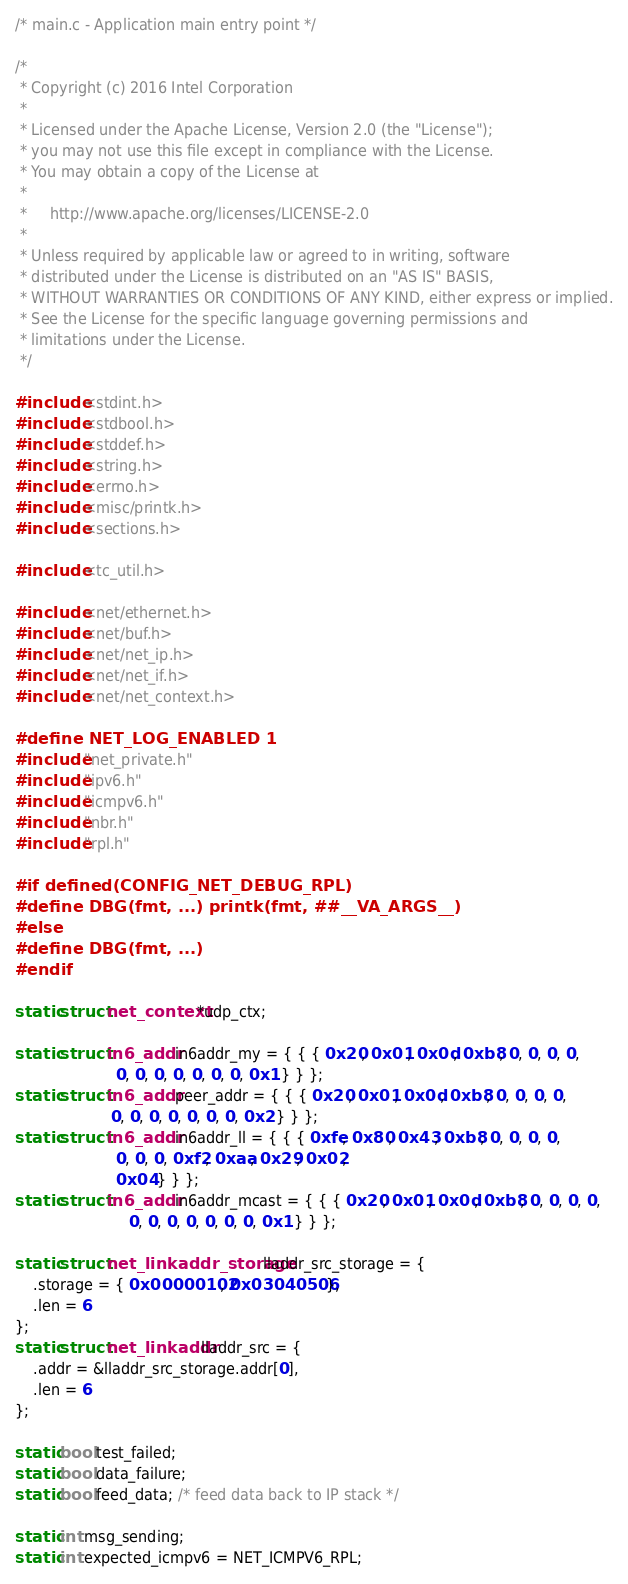<code> <loc_0><loc_0><loc_500><loc_500><_C_>/* main.c - Application main entry point */

/*
 * Copyright (c) 2016 Intel Corporation
 *
 * Licensed under the Apache License, Version 2.0 (the "License");
 * you may not use this file except in compliance with the License.
 * You may obtain a copy of the License at
 *
 *     http://www.apache.org/licenses/LICENSE-2.0
 *
 * Unless required by applicable law or agreed to in writing, software
 * distributed under the License is distributed on an "AS IS" BASIS,
 * WITHOUT WARRANTIES OR CONDITIONS OF ANY KIND, either express or implied.
 * See the License for the specific language governing permissions and
 * limitations under the License.
 */

#include <stdint.h>
#include <stdbool.h>
#include <stddef.h>
#include <string.h>
#include <errno.h>
#include <misc/printk.h>
#include <sections.h>

#include <tc_util.h>

#include <net/ethernet.h>
#include <net/buf.h>
#include <net/net_ip.h>
#include <net/net_if.h>
#include <net/net_context.h>

#define NET_LOG_ENABLED 1
#include "net_private.h"
#include "ipv6.h"
#include "icmpv6.h"
#include "nbr.h"
#include "rpl.h"

#if defined(CONFIG_NET_DEBUG_RPL)
#define DBG(fmt, ...) printk(fmt, ##__VA_ARGS__)
#else
#define DBG(fmt, ...)
#endif

static struct net_context *udp_ctx;

static struct in6_addr in6addr_my = { { { 0x20, 0x01, 0x0d, 0xb8, 0, 0, 0, 0,
					  0, 0, 0, 0, 0, 0, 0, 0x1 } } };
static struct in6_addr peer_addr = { { { 0x20, 0x01, 0x0d, 0xb8, 0, 0, 0, 0,
					 0, 0, 0, 0, 0, 0, 0, 0x2 } } };
static struct in6_addr in6addr_ll = { { { 0xfe, 0x80, 0x43, 0xb8, 0, 0, 0, 0,
					  0, 0, 0, 0xf2, 0xaa, 0x29, 0x02,
					  0x04 } } };
static struct in6_addr in6addr_mcast = { { { 0x20, 0x01, 0x0d, 0xb8, 0, 0, 0, 0,
					     0, 0, 0, 0, 0, 0, 0, 0x1 } } };

static struct net_linkaddr_storage lladdr_src_storage = {
	.storage = { 0x00000102, 0x03040506 },
	.len = 6
};
static struct net_linkaddr lladdr_src = {
	.addr = &lladdr_src_storage.addr[0],
	.len = 6
};

static bool test_failed;
static bool data_failure;
static bool feed_data; /* feed data back to IP stack */

static int msg_sending;
static int expected_icmpv6 = NET_ICMPV6_RPL;
</code> 